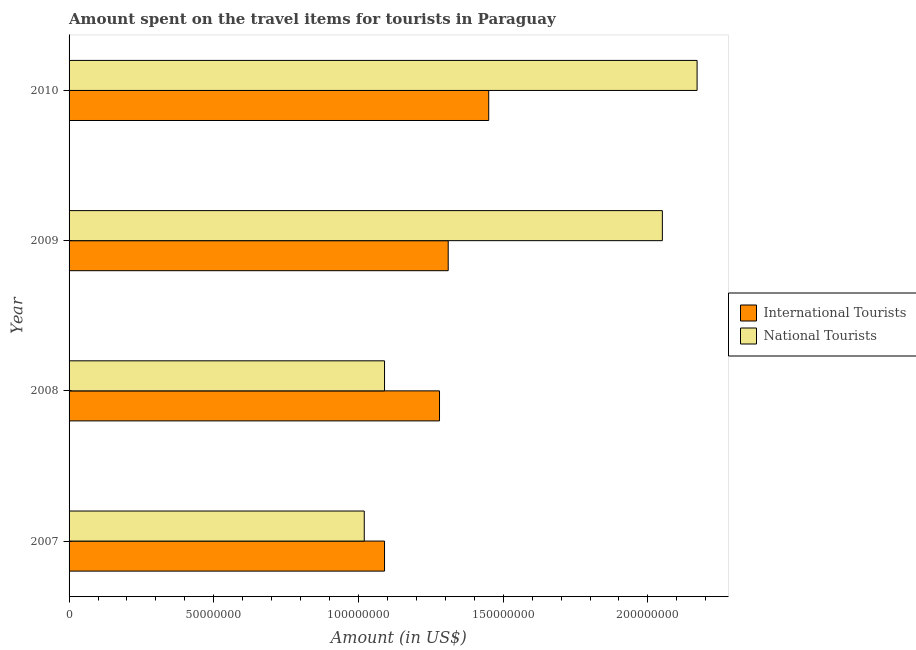How many different coloured bars are there?
Your response must be concise. 2. Are the number of bars per tick equal to the number of legend labels?
Your response must be concise. Yes. Are the number of bars on each tick of the Y-axis equal?
Ensure brevity in your answer.  Yes. What is the amount spent on travel items of national tourists in 2007?
Your answer should be very brief. 1.02e+08. Across all years, what is the maximum amount spent on travel items of international tourists?
Your answer should be compact. 1.45e+08. Across all years, what is the minimum amount spent on travel items of national tourists?
Provide a succinct answer. 1.02e+08. What is the total amount spent on travel items of international tourists in the graph?
Give a very brief answer. 5.13e+08. What is the difference between the amount spent on travel items of international tourists in 2007 and that in 2010?
Give a very brief answer. -3.60e+07. What is the difference between the amount spent on travel items of international tourists in 2008 and the amount spent on travel items of national tourists in 2007?
Offer a very short reply. 2.60e+07. What is the average amount spent on travel items of national tourists per year?
Provide a succinct answer. 1.58e+08. In the year 2009, what is the difference between the amount spent on travel items of national tourists and amount spent on travel items of international tourists?
Offer a terse response. 7.40e+07. What is the ratio of the amount spent on travel items of international tourists in 2007 to that in 2008?
Offer a terse response. 0.85. Is the difference between the amount spent on travel items of international tourists in 2008 and 2010 greater than the difference between the amount spent on travel items of national tourists in 2008 and 2010?
Make the answer very short. Yes. What is the difference between the highest and the second highest amount spent on travel items of international tourists?
Your answer should be compact. 1.40e+07. What is the difference between the highest and the lowest amount spent on travel items of national tourists?
Provide a succinct answer. 1.15e+08. What does the 1st bar from the top in 2010 represents?
Offer a very short reply. National Tourists. What does the 1st bar from the bottom in 2007 represents?
Offer a very short reply. International Tourists. How many bars are there?
Keep it short and to the point. 8. How many years are there in the graph?
Your answer should be compact. 4. Does the graph contain any zero values?
Your response must be concise. No. How are the legend labels stacked?
Ensure brevity in your answer.  Vertical. What is the title of the graph?
Ensure brevity in your answer.  Amount spent on the travel items for tourists in Paraguay. What is the label or title of the X-axis?
Your answer should be very brief. Amount (in US$). What is the Amount (in US$) of International Tourists in 2007?
Your answer should be very brief. 1.09e+08. What is the Amount (in US$) in National Tourists in 2007?
Ensure brevity in your answer.  1.02e+08. What is the Amount (in US$) in International Tourists in 2008?
Provide a succinct answer. 1.28e+08. What is the Amount (in US$) of National Tourists in 2008?
Offer a very short reply. 1.09e+08. What is the Amount (in US$) of International Tourists in 2009?
Provide a succinct answer. 1.31e+08. What is the Amount (in US$) in National Tourists in 2009?
Keep it short and to the point. 2.05e+08. What is the Amount (in US$) in International Tourists in 2010?
Provide a short and direct response. 1.45e+08. What is the Amount (in US$) of National Tourists in 2010?
Make the answer very short. 2.17e+08. Across all years, what is the maximum Amount (in US$) of International Tourists?
Ensure brevity in your answer.  1.45e+08. Across all years, what is the maximum Amount (in US$) of National Tourists?
Make the answer very short. 2.17e+08. Across all years, what is the minimum Amount (in US$) in International Tourists?
Your answer should be very brief. 1.09e+08. Across all years, what is the minimum Amount (in US$) of National Tourists?
Ensure brevity in your answer.  1.02e+08. What is the total Amount (in US$) in International Tourists in the graph?
Keep it short and to the point. 5.13e+08. What is the total Amount (in US$) in National Tourists in the graph?
Provide a succinct answer. 6.33e+08. What is the difference between the Amount (in US$) in International Tourists in 2007 and that in 2008?
Give a very brief answer. -1.90e+07. What is the difference between the Amount (in US$) of National Tourists in 2007 and that in 2008?
Your answer should be very brief. -7.00e+06. What is the difference between the Amount (in US$) of International Tourists in 2007 and that in 2009?
Keep it short and to the point. -2.20e+07. What is the difference between the Amount (in US$) in National Tourists in 2007 and that in 2009?
Provide a succinct answer. -1.03e+08. What is the difference between the Amount (in US$) in International Tourists in 2007 and that in 2010?
Your answer should be compact. -3.60e+07. What is the difference between the Amount (in US$) of National Tourists in 2007 and that in 2010?
Keep it short and to the point. -1.15e+08. What is the difference between the Amount (in US$) in International Tourists in 2008 and that in 2009?
Your answer should be compact. -3.00e+06. What is the difference between the Amount (in US$) in National Tourists in 2008 and that in 2009?
Your response must be concise. -9.60e+07. What is the difference between the Amount (in US$) of International Tourists in 2008 and that in 2010?
Provide a succinct answer. -1.70e+07. What is the difference between the Amount (in US$) in National Tourists in 2008 and that in 2010?
Keep it short and to the point. -1.08e+08. What is the difference between the Amount (in US$) of International Tourists in 2009 and that in 2010?
Offer a very short reply. -1.40e+07. What is the difference between the Amount (in US$) of National Tourists in 2009 and that in 2010?
Provide a short and direct response. -1.20e+07. What is the difference between the Amount (in US$) in International Tourists in 2007 and the Amount (in US$) in National Tourists in 2009?
Make the answer very short. -9.60e+07. What is the difference between the Amount (in US$) in International Tourists in 2007 and the Amount (in US$) in National Tourists in 2010?
Your answer should be compact. -1.08e+08. What is the difference between the Amount (in US$) of International Tourists in 2008 and the Amount (in US$) of National Tourists in 2009?
Your answer should be very brief. -7.70e+07. What is the difference between the Amount (in US$) of International Tourists in 2008 and the Amount (in US$) of National Tourists in 2010?
Provide a succinct answer. -8.90e+07. What is the difference between the Amount (in US$) in International Tourists in 2009 and the Amount (in US$) in National Tourists in 2010?
Ensure brevity in your answer.  -8.60e+07. What is the average Amount (in US$) of International Tourists per year?
Offer a very short reply. 1.28e+08. What is the average Amount (in US$) in National Tourists per year?
Your answer should be very brief. 1.58e+08. In the year 2007, what is the difference between the Amount (in US$) in International Tourists and Amount (in US$) in National Tourists?
Ensure brevity in your answer.  7.00e+06. In the year 2008, what is the difference between the Amount (in US$) of International Tourists and Amount (in US$) of National Tourists?
Offer a very short reply. 1.90e+07. In the year 2009, what is the difference between the Amount (in US$) in International Tourists and Amount (in US$) in National Tourists?
Offer a very short reply. -7.40e+07. In the year 2010, what is the difference between the Amount (in US$) in International Tourists and Amount (in US$) in National Tourists?
Make the answer very short. -7.20e+07. What is the ratio of the Amount (in US$) of International Tourists in 2007 to that in 2008?
Offer a very short reply. 0.85. What is the ratio of the Amount (in US$) of National Tourists in 2007 to that in 2008?
Your response must be concise. 0.94. What is the ratio of the Amount (in US$) of International Tourists in 2007 to that in 2009?
Provide a short and direct response. 0.83. What is the ratio of the Amount (in US$) of National Tourists in 2007 to that in 2009?
Your response must be concise. 0.5. What is the ratio of the Amount (in US$) of International Tourists in 2007 to that in 2010?
Provide a short and direct response. 0.75. What is the ratio of the Amount (in US$) of National Tourists in 2007 to that in 2010?
Offer a terse response. 0.47. What is the ratio of the Amount (in US$) of International Tourists in 2008 to that in 2009?
Offer a very short reply. 0.98. What is the ratio of the Amount (in US$) in National Tourists in 2008 to that in 2009?
Your answer should be very brief. 0.53. What is the ratio of the Amount (in US$) of International Tourists in 2008 to that in 2010?
Your answer should be very brief. 0.88. What is the ratio of the Amount (in US$) in National Tourists in 2008 to that in 2010?
Give a very brief answer. 0.5. What is the ratio of the Amount (in US$) in International Tourists in 2009 to that in 2010?
Your answer should be very brief. 0.9. What is the ratio of the Amount (in US$) in National Tourists in 2009 to that in 2010?
Provide a short and direct response. 0.94. What is the difference between the highest and the second highest Amount (in US$) in International Tourists?
Your answer should be very brief. 1.40e+07. What is the difference between the highest and the second highest Amount (in US$) of National Tourists?
Your answer should be very brief. 1.20e+07. What is the difference between the highest and the lowest Amount (in US$) in International Tourists?
Offer a terse response. 3.60e+07. What is the difference between the highest and the lowest Amount (in US$) of National Tourists?
Ensure brevity in your answer.  1.15e+08. 